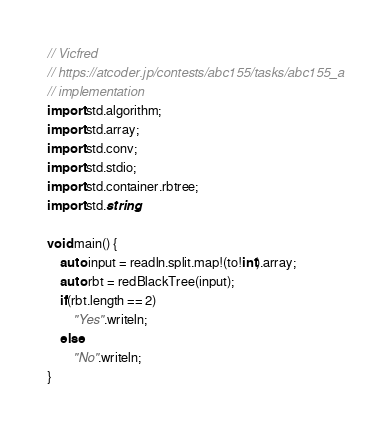<code> <loc_0><loc_0><loc_500><loc_500><_D_>// Vicfred
// https://atcoder.jp/contests/abc155/tasks/abc155_a
// implementation
import std.algorithm;
import std.array;
import std.conv;
import std.stdio;
import std.container.rbtree;
import std.string;

void main() {
    auto input = readln.split.map!(to!int).array;
    auto rbt = redBlackTree(input);
    if(rbt.length == 2)
        "Yes".writeln;
    else
        "No".writeln;
}

</code> 